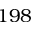Convert formula to latex. <formula><loc_0><loc_0><loc_500><loc_500>1 9 8</formula> 